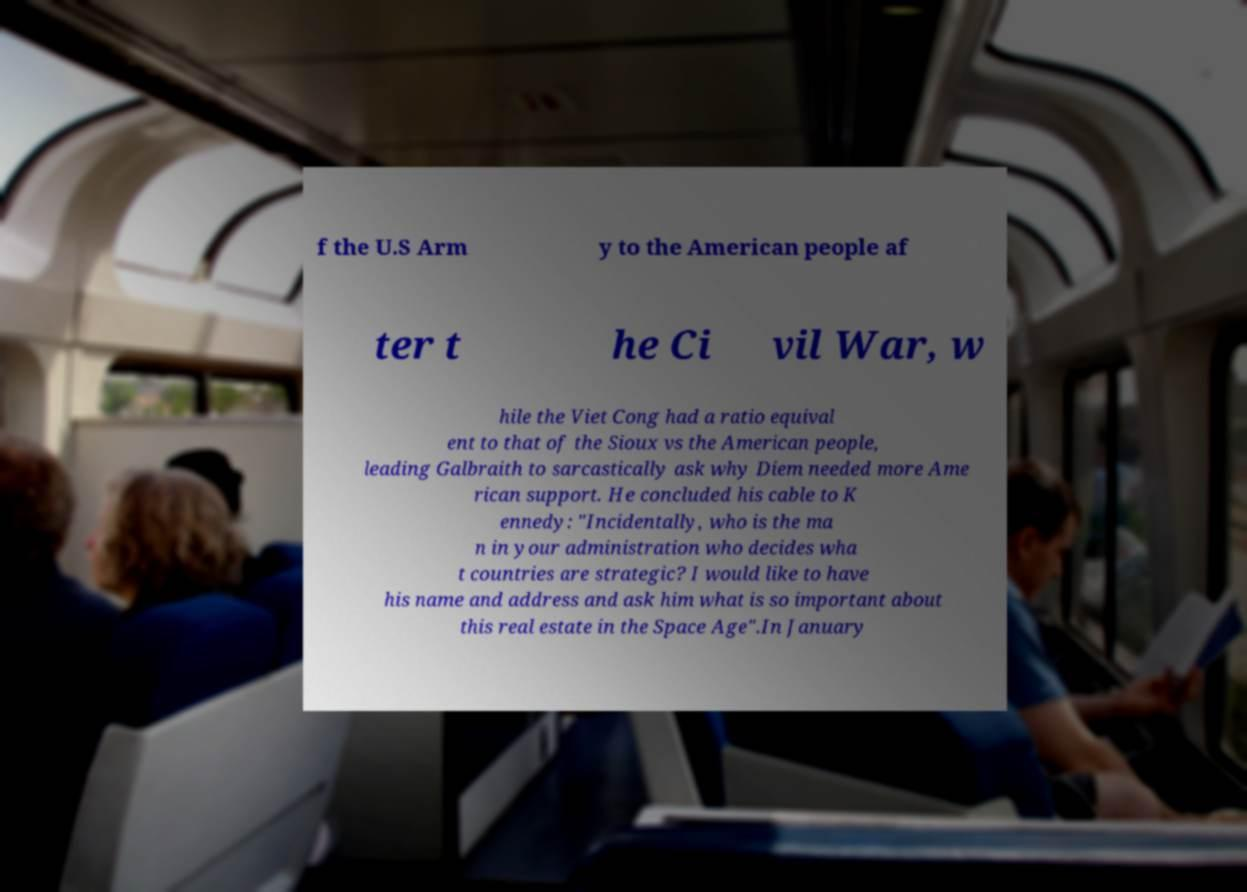Please identify and transcribe the text found in this image. f the U.S Arm y to the American people af ter t he Ci vil War, w hile the Viet Cong had a ratio equival ent to that of the Sioux vs the American people, leading Galbraith to sarcastically ask why Diem needed more Ame rican support. He concluded his cable to K ennedy: "Incidentally, who is the ma n in your administration who decides wha t countries are strategic? I would like to have his name and address and ask him what is so important about this real estate in the Space Age".In January 